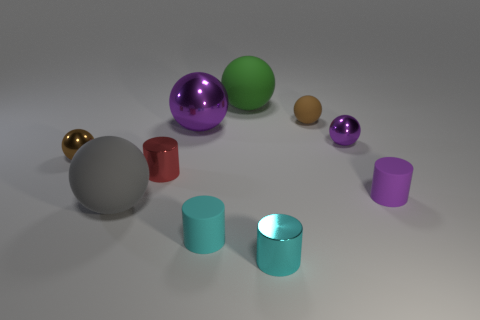Are there an equal number of small shiny spheres that are on the left side of the tiny purple shiny sphere and tiny brown metallic spheres on the right side of the small brown metallic sphere?
Make the answer very short. No. There is a cyan matte thing; is it the same size as the gray sphere on the left side of the red shiny cylinder?
Ensure brevity in your answer.  No. There is a small metal thing that is in front of the tiny cyan rubber object; are there any large green matte things that are in front of it?
Offer a very short reply. No. Are there any red objects of the same shape as the tiny purple matte object?
Your response must be concise. Yes. There is a matte object right of the small shiny thing that is to the right of the tiny cyan metallic cylinder; what number of purple matte cylinders are in front of it?
Provide a short and direct response. 0. There is a large metallic ball; does it have the same color as the big thing in front of the tiny purple matte cylinder?
Ensure brevity in your answer.  No. What number of things are either small purple balls behind the purple rubber object or cylinders in front of the big gray thing?
Offer a very short reply. 3. Is the number of big rubber objects that are to the right of the green rubber sphere greater than the number of brown things to the right of the tiny red metal cylinder?
Your answer should be compact. No. What material is the brown object left of the gray rubber ball that is on the left side of the tiny metal cylinder in front of the tiny purple matte cylinder?
Keep it short and to the point. Metal. Does the large rubber thing behind the purple cylinder have the same shape as the small rubber object that is left of the green matte ball?
Give a very brief answer. No. 